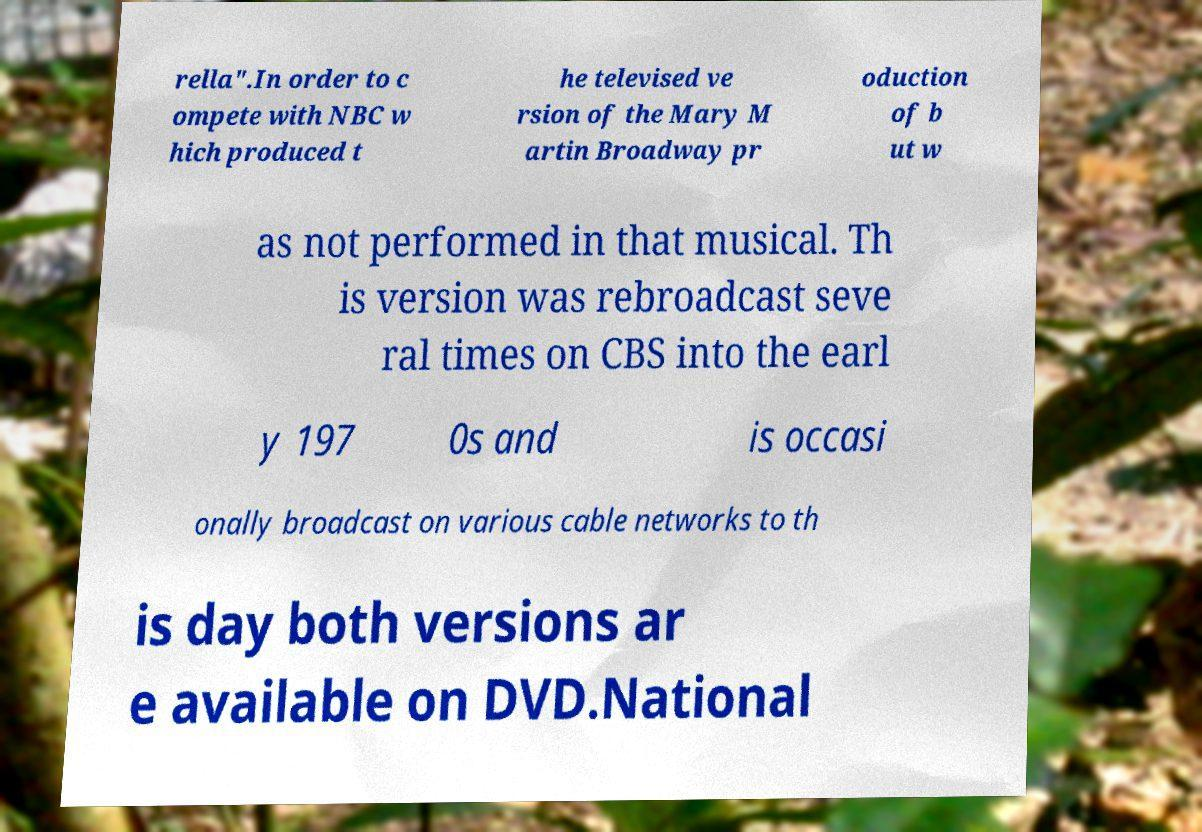Can you read and provide the text displayed in the image?This photo seems to have some interesting text. Can you extract and type it out for me? rella".In order to c ompete with NBC w hich produced t he televised ve rsion of the Mary M artin Broadway pr oduction of b ut w as not performed in that musical. Th is version was rebroadcast seve ral times on CBS into the earl y 197 0s and is occasi onally broadcast on various cable networks to th is day both versions ar e available on DVD.National 